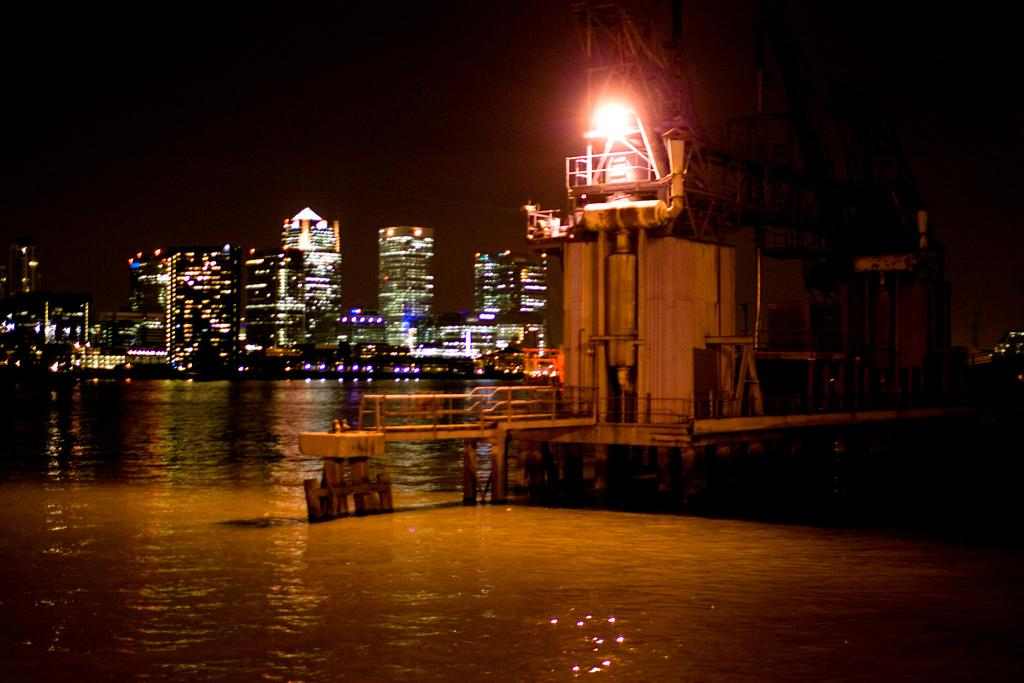What is present in the image? There is water visible in the image, as well as an object. Can you describe the background of the image? There are buildings with lights in the background of the image. What show is being performed in the middle of the water in the image? There is no show being performed in the middle of the water in the image. What time of day is depicted in the image? The provided facts do not give any information about the time of day depicted in the image. 